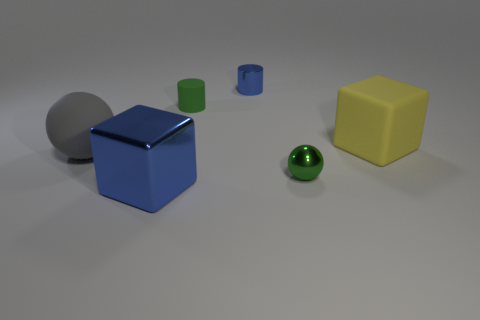Add 2 large gray rubber objects. How many objects exist? 8 Subtract all blocks. How many objects are left? 4 Subtract 0 red blocks. How many objects are left? 6 Subtract all rubber cubes. Subtract all green rubber cylinders. How many objects are left? 4 Add 6 rubber cylinders. How many rubber cylinders are left? 7 Add 4 large metallic cubes. How many large metallic cubes exist? 5 